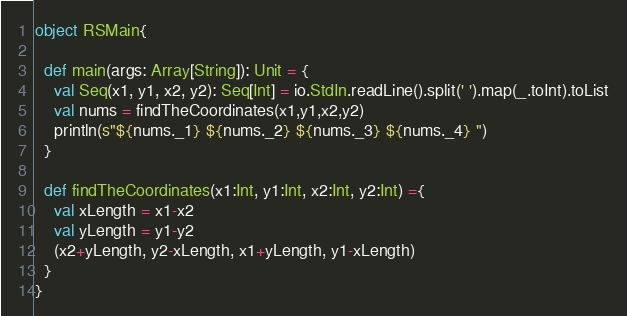Convert code to text. <code><loc_0><loc_0><loc_500><loc_500><_Scala_>object RSMain{

  def main(args: Array[String]): Unit = {
    val Seq(x1, y1, x2, y2): Seq[Int] = io.StdIn.readLine().split(' ').map(_.toInt).toList
    val nums = findTheCoordinates(x1,y1,x2,y2)
    println(s"${nums._1} ${nums._2} ${nums._3} ${nums._4} ")
  }

  def findTheCoordinates(x1:Int, y1:Int, x2:Int, y2:Int) ={
    val xLength = x1-x2
    val yLength = y1-y2
    (x2+yLength, y2-xLength, x1+yLength, y1-xLength)
  }
}</code> 